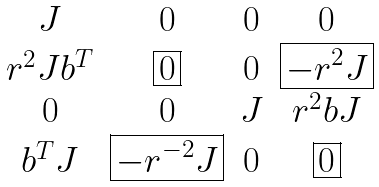<formula> <loc_0><loc_0><loc_500><loc_500>\begin{matrix} J & 0 & 0 & 0 \\ r ^ { 2 } J b ^ { T } & \boxed { 0 } & 0 & \boxed { - r ^ { 2 } J } \\ 0 & 0 & J & r ^ { 2 } b J \\ b ^ { T } J & \boxed { - r ^ { - 2 } J } & 0 & \boxed { 0 } \\ \end{matrix}</formula> 